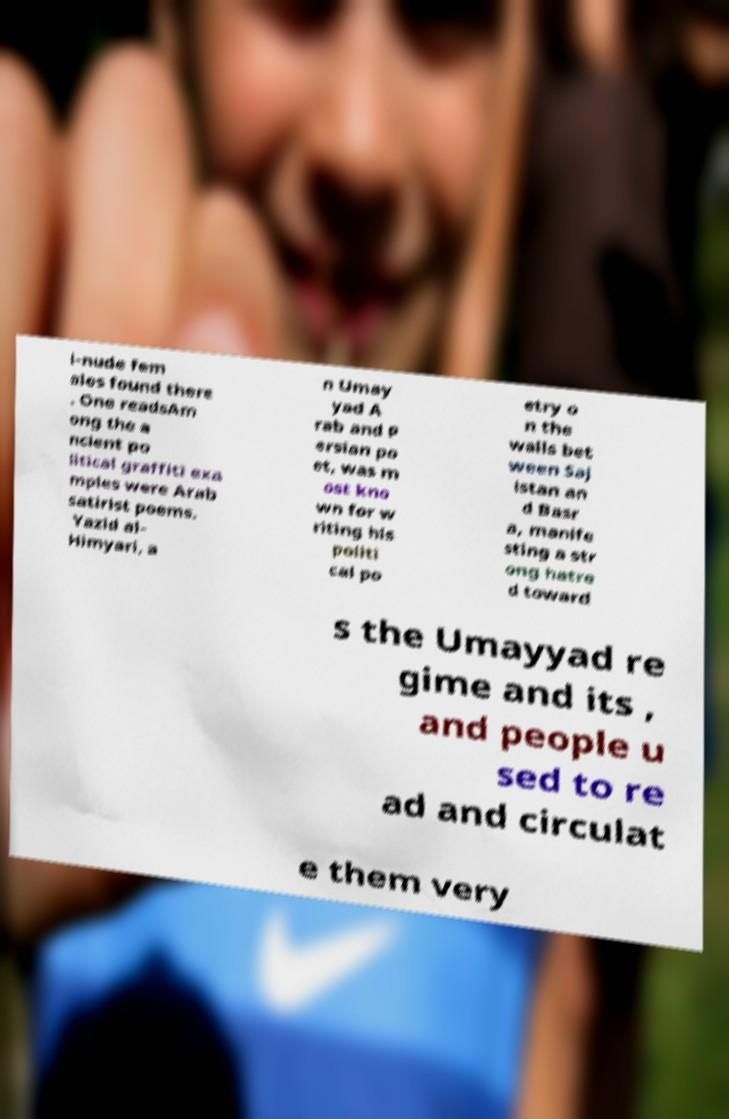Could you extract and type out the text from this image? i-nude fem ales found there . One readsAm ong the a ncient po litical graffiti exa mples were Arab satirist poems. Yazid al- Himyari, a n Umay yad A rab and P ersian po et, was m ost kno wn for w riting his politi cal po etry o n the walls bet ween Saj istan an d Basr a, manife sting a str ong hatre d toward s the Umayyad re gime and its , and people u sed to re ad and circulat e them very 